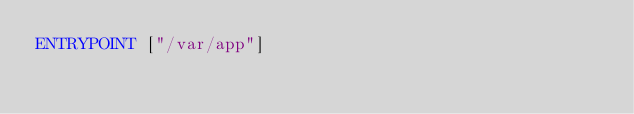<code> <loc_0><loc_0><loc_500><loc_500><_Dockerfile_>ENTRYPOINT ["/var/app"]</code> 